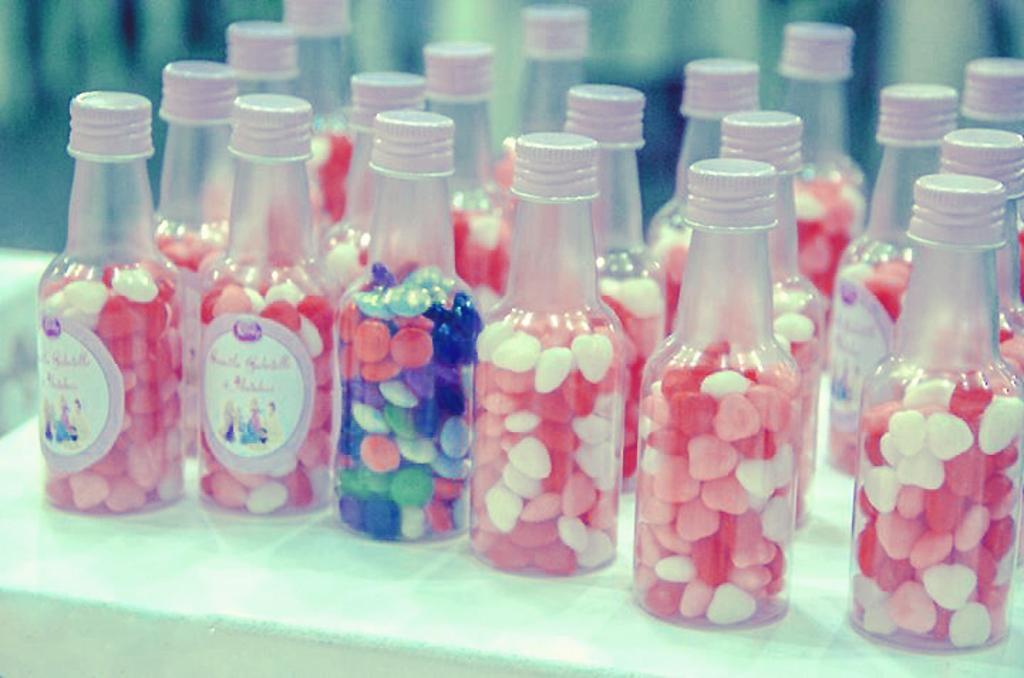Can you describe this image briefly? On a table there are many bottle with a colorful items in it. 